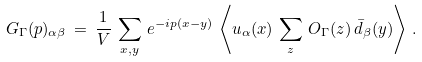<formula> <loc_0><loc_0><loc_500><loc_500>G _ { \Gamma } ( p ) _ { \alpha \beta } \, = \, \frac { 1 } { V } \, \sum _ { x , y } \, e ^ { - i p ( x - y ) } \, \left \langle u _ { \alpha } ( x ) \, \sum _ { z } \, O _ { \Gamma } ( z ) \, \bar { d } _ { \beta } ( y ) \right \rangle \, .</formula> 